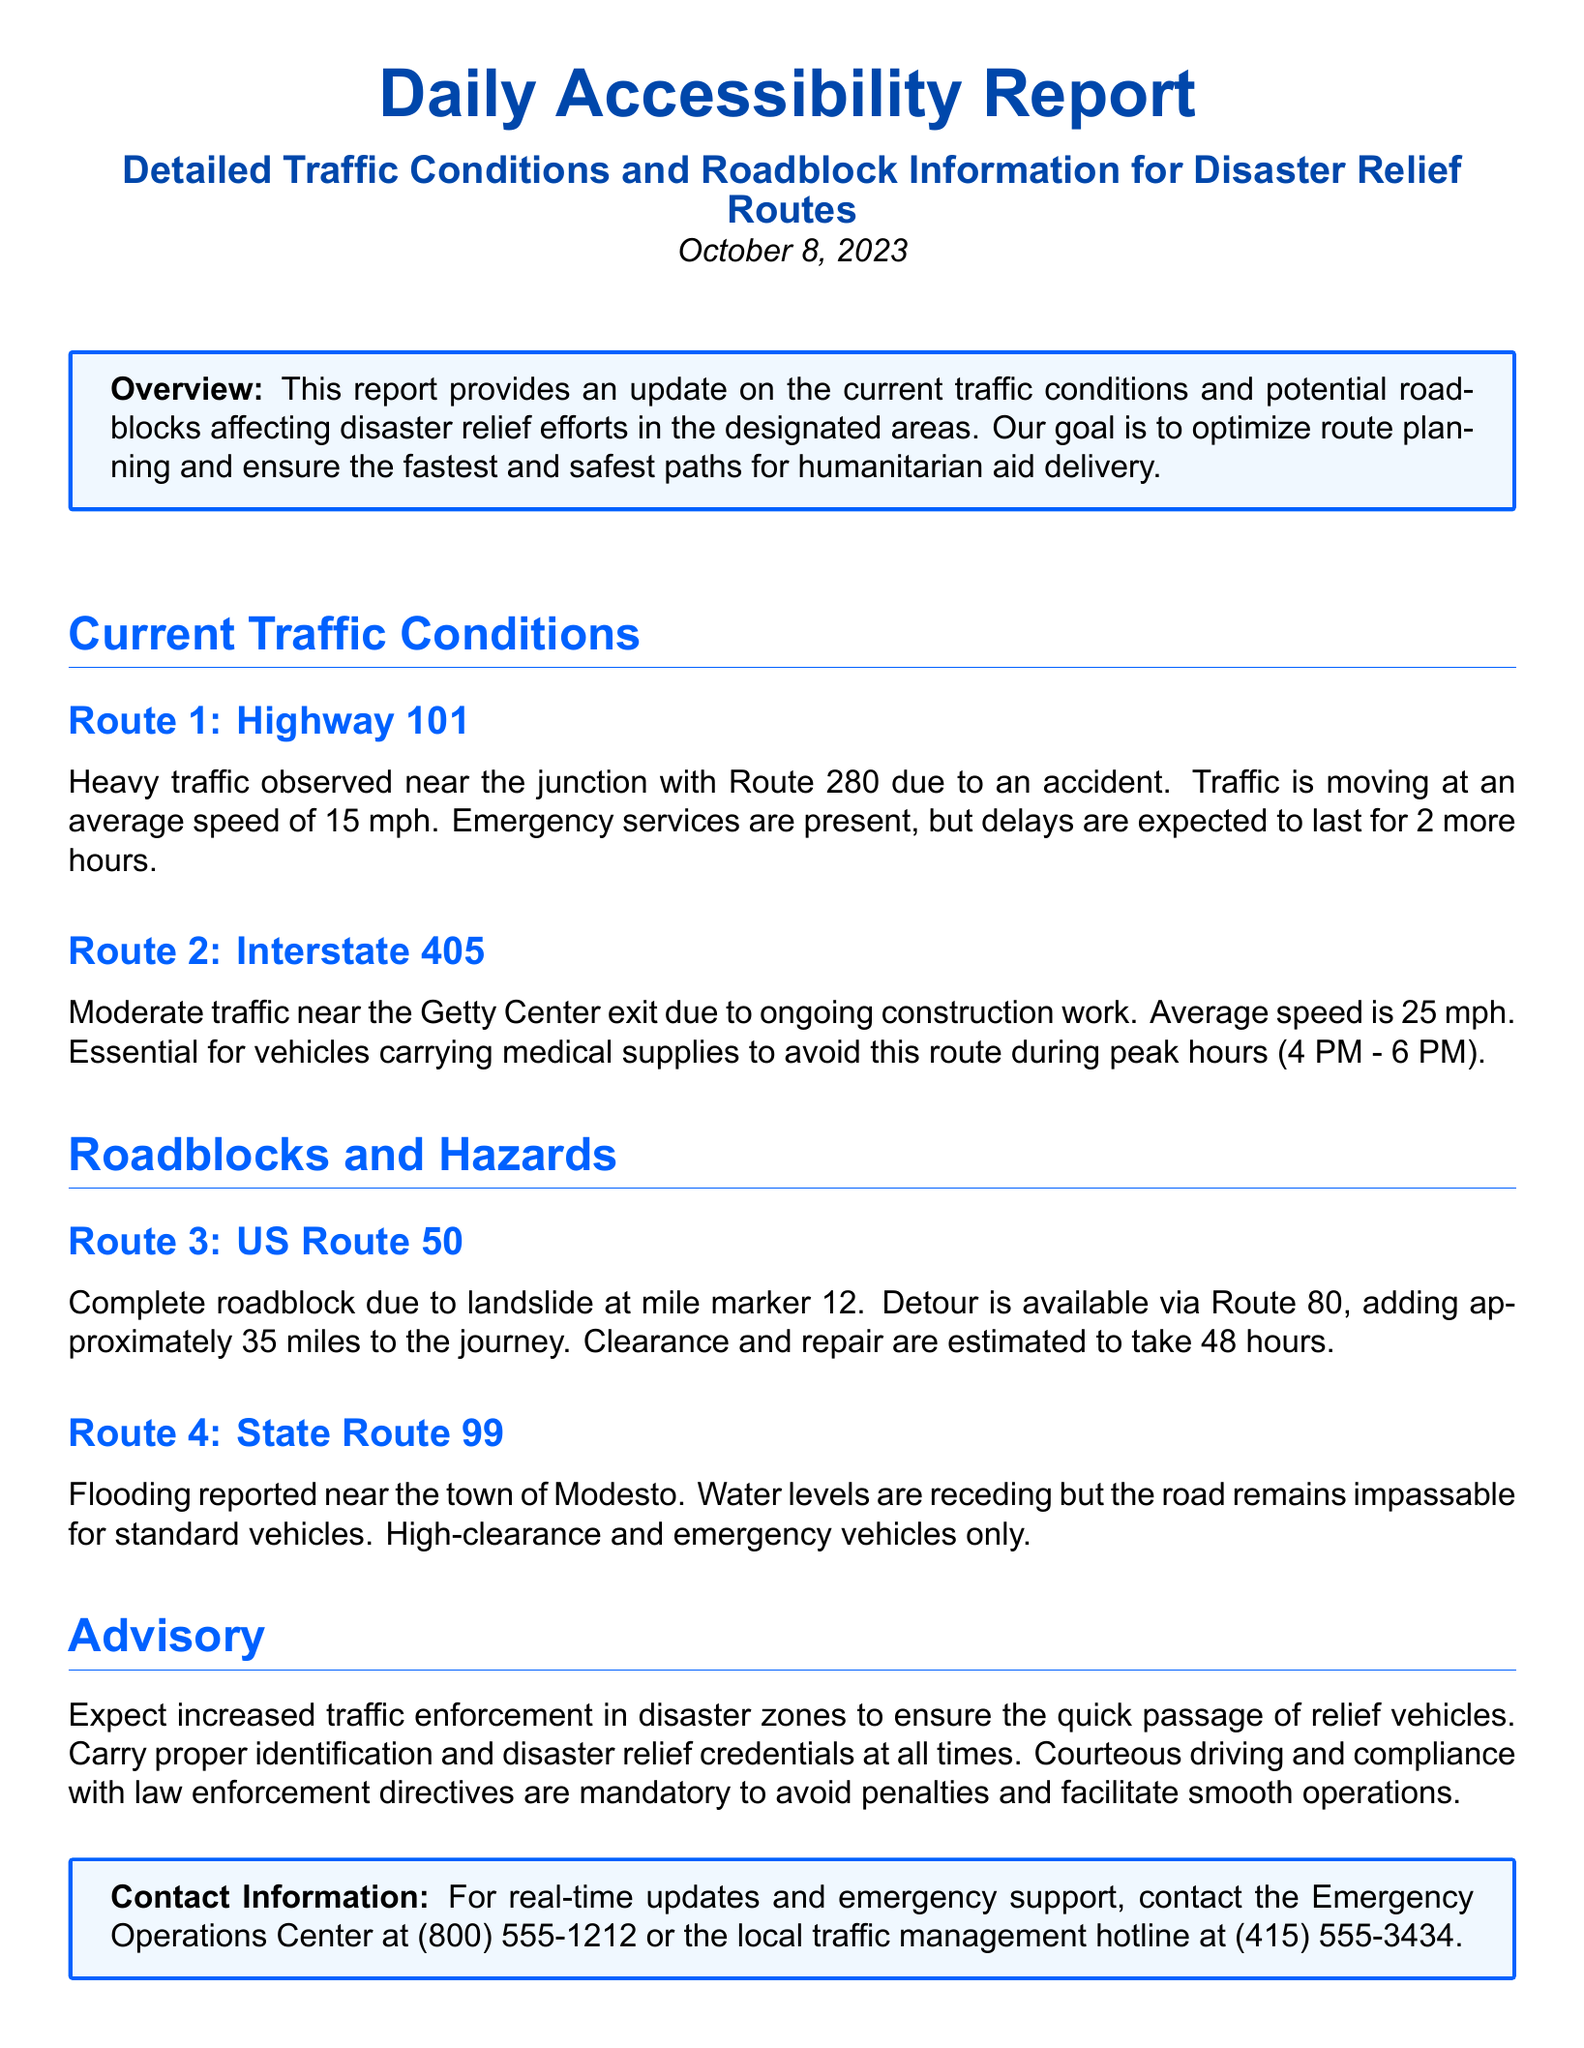What is the date of the report? The date of the report is specified at the beginning of the document, which is October 8, 2023.
Answer: October 8, 2023 What is the average speed on Highway 101? The average speed on Highway 101 is mentioned in the document as 15 mph due to heavy traffic.
Answer: 15 mph What type of vehicles can use State Route 99? The document specifies that only high-clearance and emergency vehicles can use State Route 99 due to flooding.
Answer: High-clearance and emergency vehicles How long is the detour for US Route 50? The document states that the detour for US Route 50 adds approximately 35 miles to the journey.
Answer: 35 miles What should vehicles carrying medical supplies avoid during peak hours? The document advises that vehicles carrying medical supplies should avoid Interstate 405 during peak hours from 4 PM to 6 PM due to construction work.
Answer: Interstate 405 What is causing traffic on Route 2? The document states that moderate traffic on Interstate 405 is caused by ongoing construction work near the Getty Center exit.
Answer: Ongoing construction work How long is the estimated clearance and repair time for US Route 50? The estimated clearance and repair time for US Route 50 is mentioned as 48 hours in the document.
Answer: 48 hours What is the contact number for the Emergency Operations Center? The document provides the contact number for the Emergency Operations Center as (800) 555-1212.
Answer: (800) 555-1212 